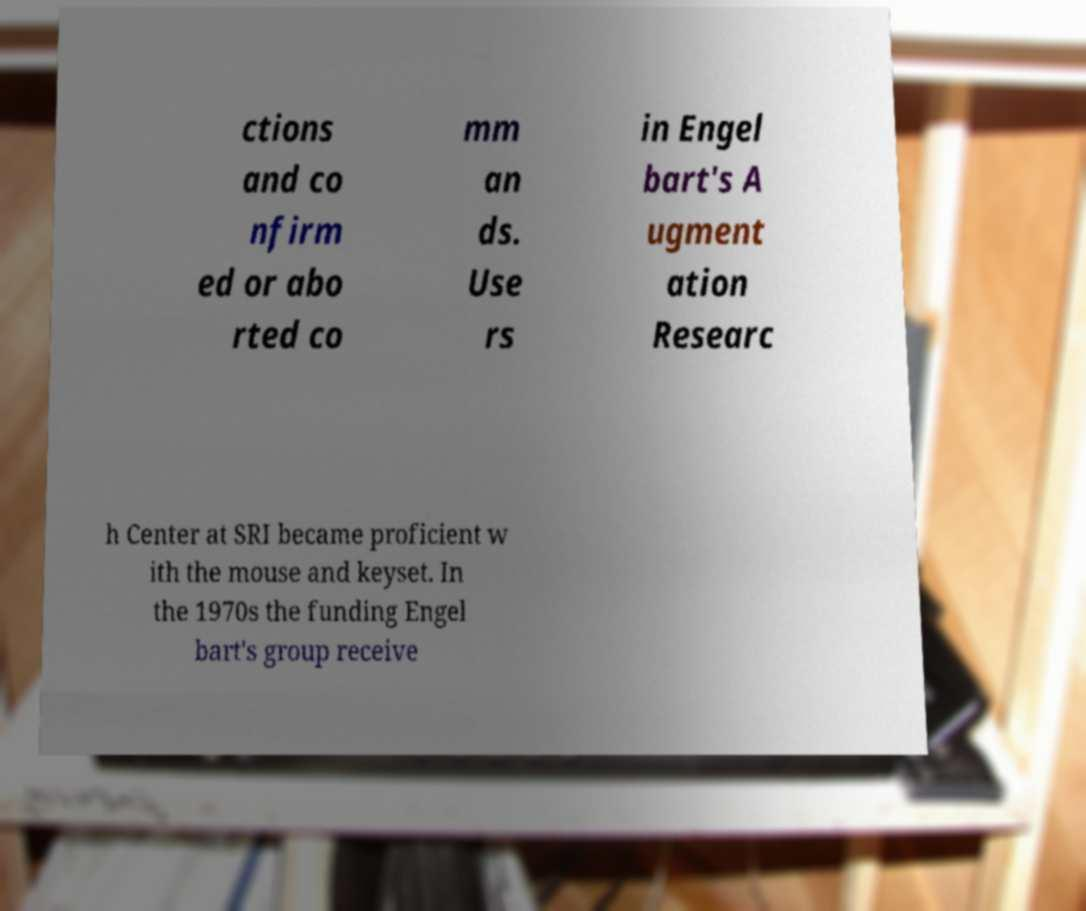Could you extract and type out the text from this image? ctions and co nfirm ed or abo rted co mm an ds. Use rs in Engel bart's A ugment ation Researc h Center at SRI became proficient w ith the mouse and keyset. In the 1970s the funding Engel bart's group receive 